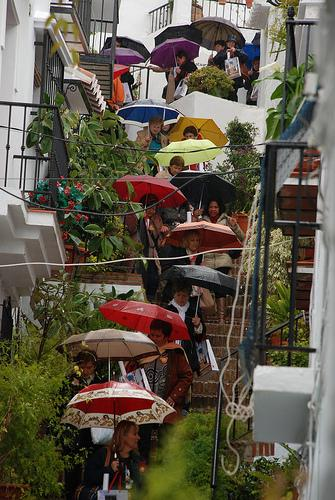Provide a concise description of the primary elements in the image. Umbrella-holding people on red brick steps, cables above, balcony, and flowers nearby. Describe the focal point of the image and the surrounding setting. Umbrella-wielding people on red brick steps accompanied by a balcony, flowers, and overhead cables. Mention the main elements of the scene and what is taking place. Individuals with umbrellas walking down red brick stairs near a balcony and flowers, with cables overhead. Identify the primary focus of the image and provide a brief explanation of the scene. People holding umbrellas walking down red brick stairs with a balcony, cables, and flowers in the background. Summarize the main components of the image briefly. Umbrella-carrying individuals on red stairs, balcony in background, flowers, and cables above. Provide a succinct account of the primary subject and setting in the image. People with umbrellas on red brick steps, alongside a balcony, flowers, and cables overhead. Give a short overview of the main objects and setting in the image. People with umbrellas on red brick staircase, flowers, a balcony, and cables above. In a few words, describe the main subject and environment of the image. Umbrella-clutching people on red steps, with balcony, flowers, and overhead cables. Outline the main subject of the image and its context. People holding umbrellas descending red brick stairs, set against a backdrop of a balcony, flowers, and cables. Briefly narrate the central theme of the image. A group of people with umbrellas descending red brick steps surrounded by flowers, a balcony, and cables. 